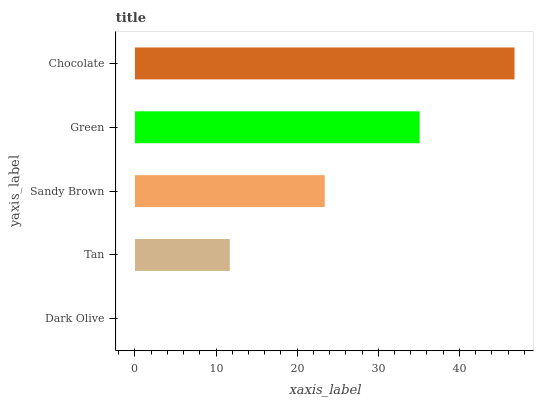Is Dark Olive the minimum?
Answer yes or no. Yes. Is Chocolate the maximum?
Answer yes or no. Yes. Is Tan the minimum?
Answer yes or no. No. Is Tan the maximum?
Answer yes or no. No. Is Tan greater than Dark Olive?
Answer yes or no. Yes. Is Dark Olive less than Tan?
Answer yes or no. Yes. Is Dark Olive greater than Tan?
Answer yes or no. No. Is Tan less than Dark Olive?
Answer yes or no. No. Is Sandy Brown the high median?
Answer yes or no. Yes. Is Sandy Brown the low median?
Answer yes or no. Yes. Is Green the high median?
Answer yes or no. No. Is Chocolate the low median?
Answer yes or no. No. 